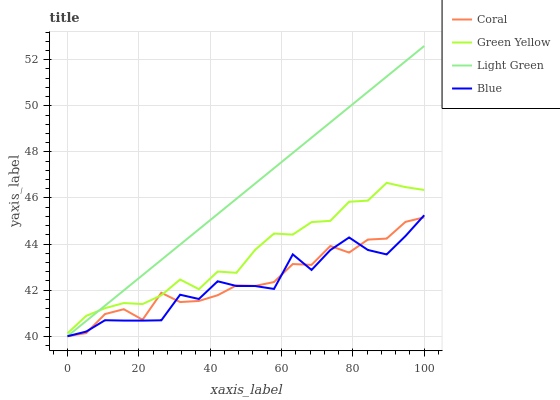Does Blue have the minimum area under the curve?
Answer yes or no. Yes. Does Light Green have the maximum area under the curve?
Answer yes or no. Yes. Does Coral have the minimum area under the curve?
Answer yes or no. No. Does Coral have the maximum area under the curve?
Answer yes or no. No. Is Light Green the smoothest?
Answer yes or no. Yes. Is Blue the roughest?
Answer yes or no. Yes. Is Coral the smoothest?
Answer yes or no. No. Is Coral the roughest?
Answer yes or no. No. Does Blue have the lowest value?
Answer yes or no. Yes. Does Green Yellow have the lowest value?
Answer yes or no. No. Does Light Green have the highest value?
Answer yes or no. Yes. Does Green Yellow have the highest value?
Answer yes or no. No. Is Blue less than Green Yellow?
Answer yes or no. Yes. Is Green Yellow greater than Blue?
Answer yes or no. Yes. Does Blue intersect Light Green?
Answer yes or no. Yes. Is Blue less than Light Green?
Answer yes or no. No. Is Blue greater than Light Green?
Answer yes or no. No. Does Blue intersect Green Yellow?
Answer yes or no. No. 